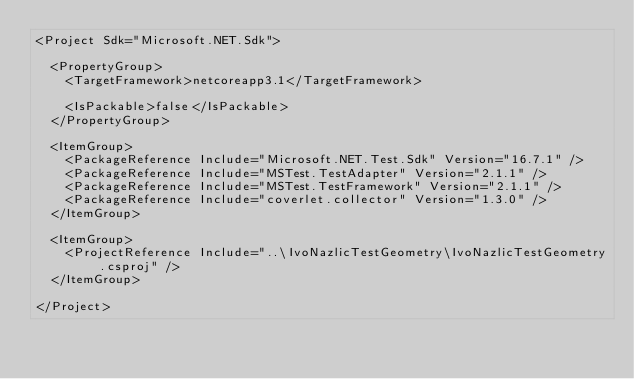<code> <loc_0><loc_0><loc_500><loc_500><_XML_><Project Sdk="Microsoft.NET.Sdk">

  <PropertyGroup>
    <TargetFramework>netcoreapp3.1</TargetFramework>

    <IsPackable>false</IsPackable>
  </PropertyGroup>

  <ItemGroup>
    <PackageReference Include="Microsoft.NET.Test.Sdk" Version="16.7.1" />
    <PackageReference Include="MSTest.TestAdapter" Version="2.1.1" />
    <PackageReference Include="MSTest.TestFramework" Version="2.1.1" />
    <PackageReference Include="coverlet.collector" Version="1.3.0" />
  </ItemGroup>

  <ItemGroup>
    <ProjectReference Include="..\IvoNazlicTestGeometry\IvoNazlicTestGeometry.csproj" />
  </ItemGroup>

</Project>
</code> 